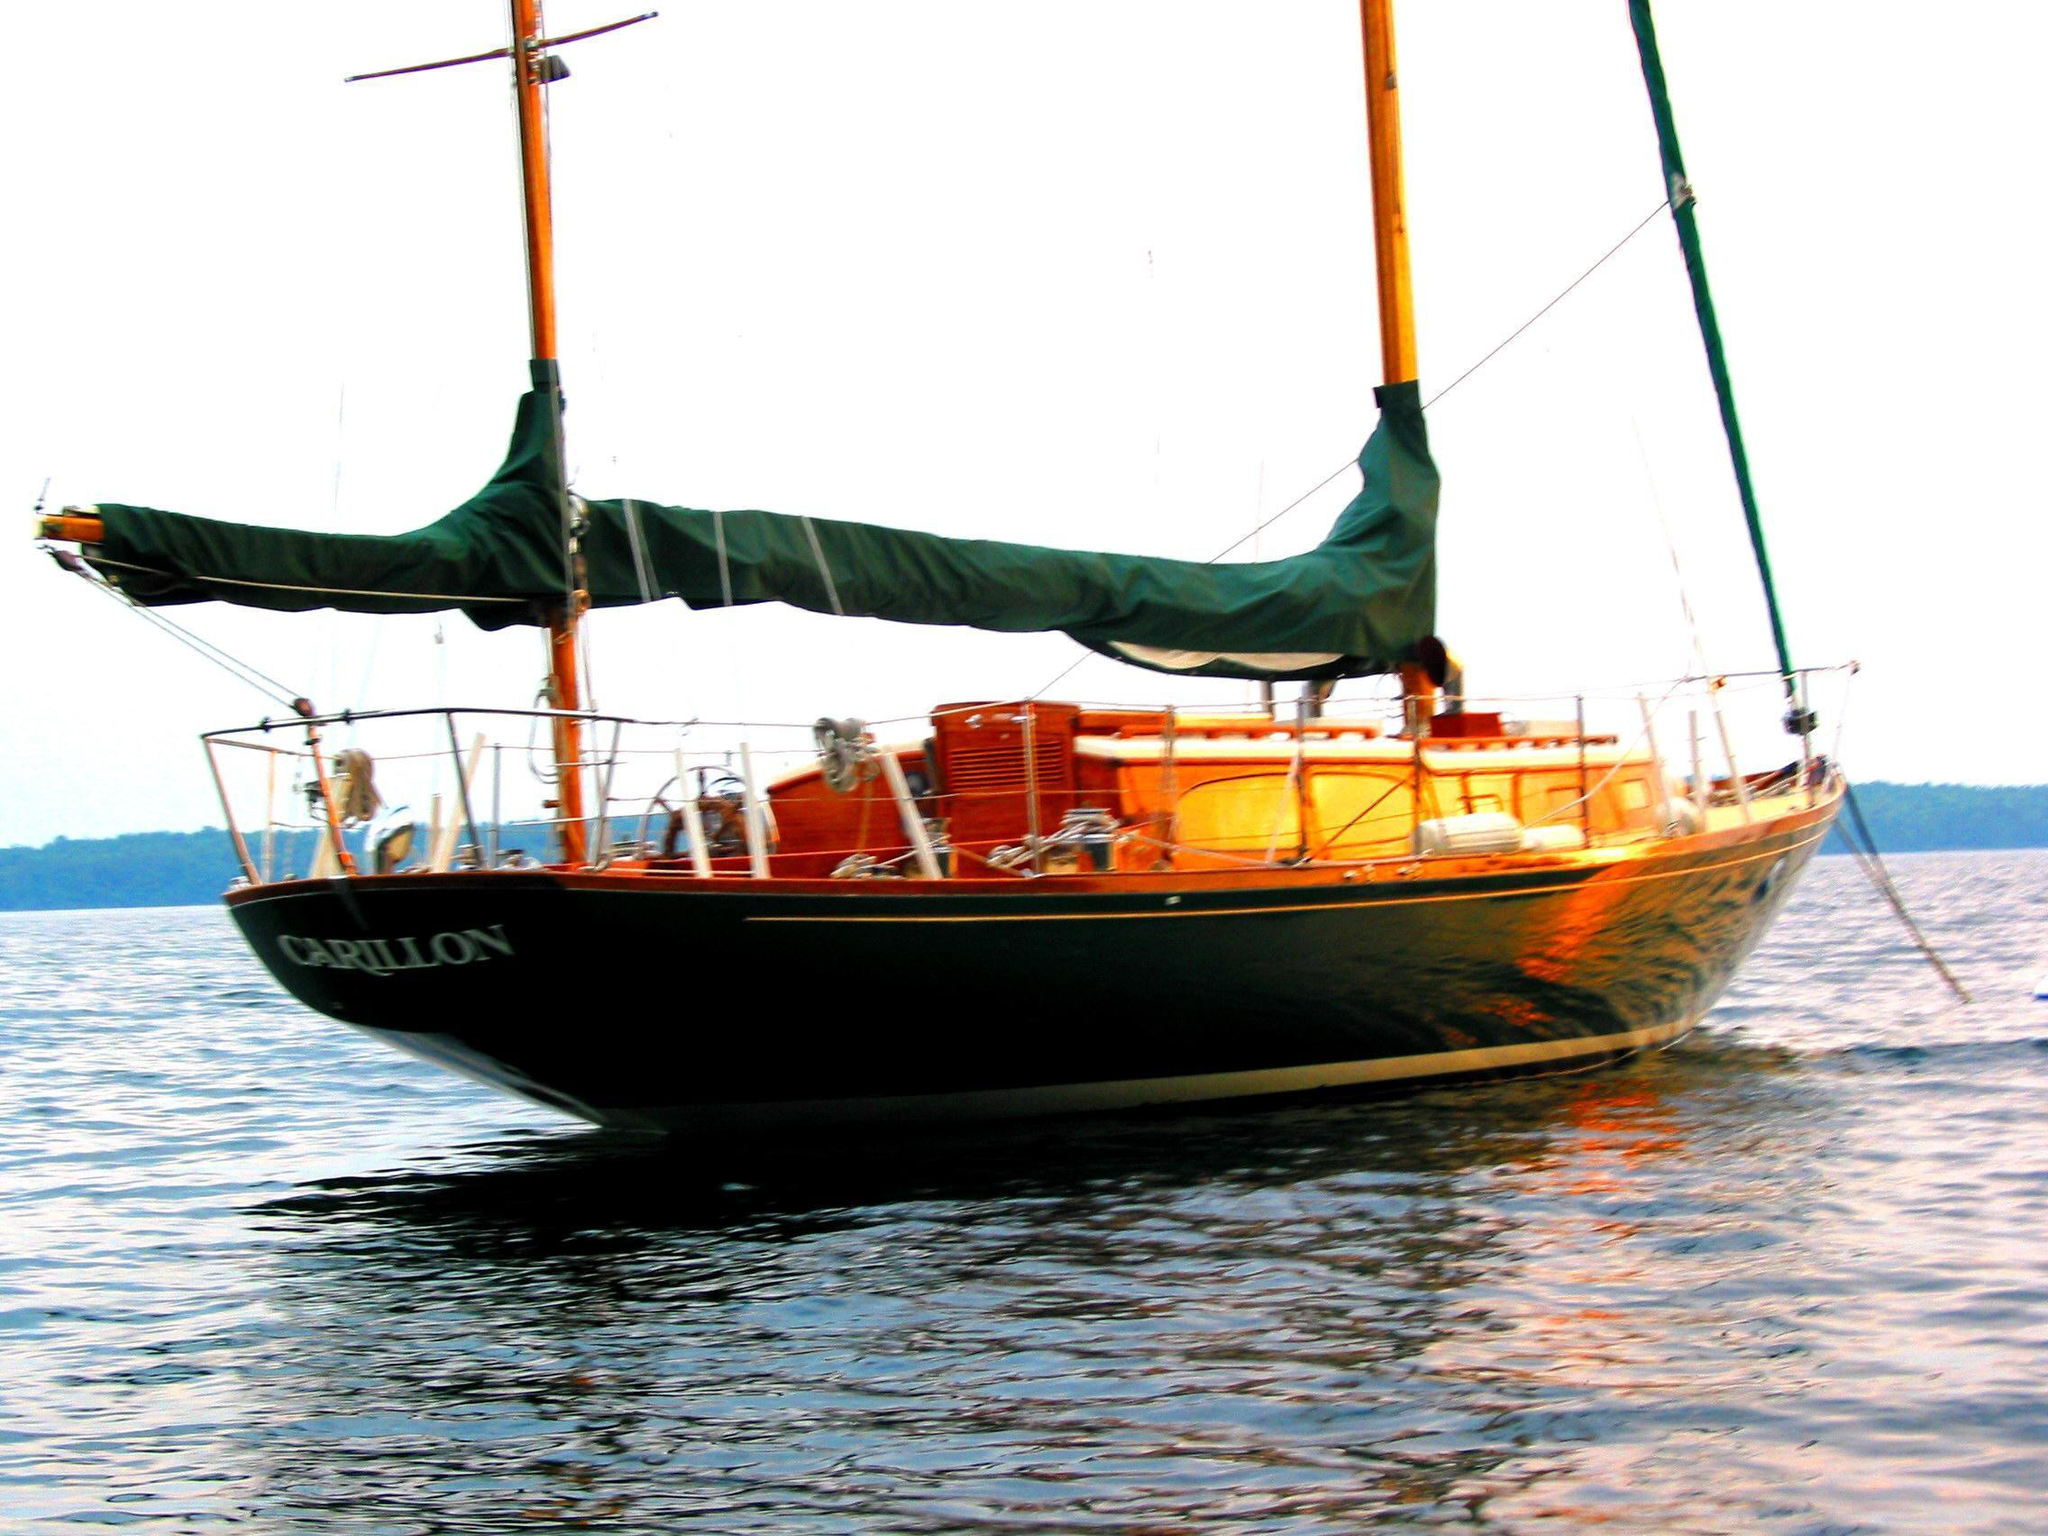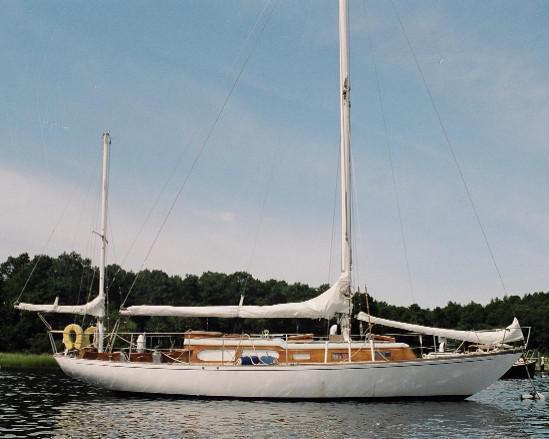The first image is the image on the left, the second image is the image on the right. Evaluate the accuracy of this statement regarding the images: "there are white inflated sails in the image on the right". Is it true? Answer yes or no. No. The first image is the image on the left, the second image is the image on the right. Examine the images to the left and right. Is the description "At least one sailboat has white sails unfurled." accurate? Answer yes or no. No. 